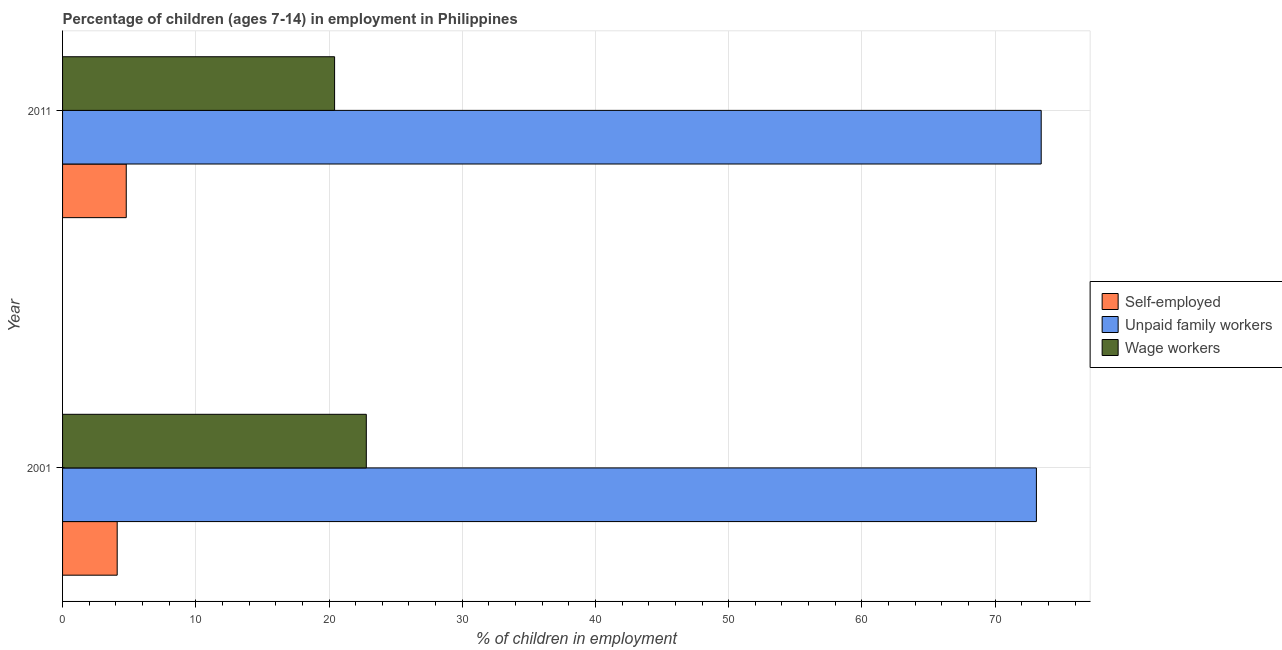How many groups of bars are there?
Provide a short and direct response. 2. Are the number of bars per tick equal to the number of legend labels?
Provide a succinct answer. Yes. What is the label of the 2nd group of bars from the top?
Make the answer very short. 2001. In how many cases, is the number of bars for a given year not equal to the number of legend labels?
Keep it short and to the point. 0. What is the percentage of children employed as wage workers in 2011?
Provide a succinct answer. 20.42. Across all years, what is the maximum percentage of self employed children?
Your response must be concise. 4.78. Across all years, what is the minimum percentage of children employed as wage workers?
Provide a succinct answer. 20.42. In which year was the percentage of self employed children maximum?
Offer a very short reply. 2011. In which year was the percentage of children employed as unpaid family workers minimum?
Keep it short and to the point. 2001. What is the total percentage of children employed as wage workers in the graph?
Keep it short and to the point. 43.22. What is the difference between the percentage of self employed children in 2001 and that in 2011?
Offer a very short reply. -0.68. What is the difference between the percentage of children employed as wage workers in 2001 and the percentage of children employed as unpaid family workers in 2011?
Offer a terse response. -50.66. What is the average percentage of self employed children per year?
Ensure brevity in your answer.  4.44. In the year 2001, what is the difference between the percentage of children employed as wage workers and percentage of self employed children?
Offer a terse response. 18.7. What is the ratio of the percentage of self employed children in 2001 to that in 2011?
Offer a very short reply. 0.86. Is the percentage of self employed children in 2001 less than that in 2011?
Ensure brevity in your answer.  Yes. Is the difference between the percentage of children employed as wage workers in 2001 and 2011 greater than the difference between the percentage of self employed children in 2001 and 2011?
Provide a short and direct response. Yes. In how many years, is the percentage of self employed children greater than the average percentage of self employed children taken over all years?
Your answer should be very brief. 1. What does the 3rd bar from the top in 2001 represents?
Offer a terse response. Self-employed. What does the 2nd bar from the bottom in 2011 represents?
Make the answer very short. Unpaid family workers. Is it the case that in every year, the sum of the percentage of self employed children and percentage of children employed as unpaid family workers is greater than the percentage of children employed as wage workers?
Offer a terse response. Yes. How many bars are there?
Your response must be concise. 6. Are all the bars in the graph horizontal?
Your answer should be very brief. Yes. Are the values on the major ticks of X-axis written in scientific E-notation?
Provide a short and direct response. No. Does the graph contain grids?
Give a very brief answer. Yes. How many legend labels are there?
Give a very brief answer. 3. How are the legend labels stacked?
Make the answer very short. Vertical. What is the title of the graph?
Keep it short and to the point. Percentage of children (ages 7-14) in employment in Philippines. What is the label or title of the X-axis?
Offer a very short reply. % of children in employment. What is the % of children in employment in Unpaid family workers in 2001?
Your answer should be very brief. 73.1. What is the % of children in employment of Wage workers in 2001?
Give a very brief answer. 22.8. What is the % of children in employment in Self-employed in 2011?
Give a very brief answer. 4.78. What is the % of children in employment of Unpaid family workers in 2011?
Offer a very short reply. 73.46. What is the % of children in employment in Wage workers in 2011?
Provide a succinct answer. 20.42. Across all years, what is the maximum % of children in employment in Self-employed?
Your answer should be compact. 4.78. Across all years, what is the maximum % of children in employment of Unpaid family workers?
Provide a succinct answer. 73.46. Across all years, what is the maximum % of children in employment in Wage workers?
Give a very brief answer. 22.8. Across all years, what is the minimum % of children in employment of Unpaid family workers?
Offer a terse response. 73.1. Across all years, what is the minimum % of children in employment of Wage workers?
Provide a succinct answer. 20.42. What is the total % of children in employment in Self-employed in the graph?
Your answer should be compact. 8.88. What is the total % of children in employment of Unpaid family workers in the graph?
Provide a short and direct response. 146.56. What is the total % of children in employment in Wage workers in the graph?
Offer a terse response. 43.22. What is the difference between the % of children in employment of Self-employed in 2001 and that in 2011?
Your answer should be compact. -0.68. What is the difference between the % of children in employment in Unpaid family workers in 2001 and that in 2011?
Offer a terse response. -0.36. What is the difference between the % of children in employment in Wage workers in 2001 and that in 2011?
Ensure brevity in your answer.  2.38. What is the difference between the % of children in employment of Self-employed in 2001 and the % of children in employment of Unpaid family workers in 2011?
Your answer should be very brief. -69.36. What is the difference between the % of children in employment of Self-employed in 2001 and the % of children in employment of Wage workers in 2011?
Provide a succinct answer. -16.32. What is the difference between the % of children in employment of Unpaid family workers in 2001 and the % of children in employment of Wage workers in 2011?
Give a very brief answer. 52.68. What is the average % of children in employment of Self-employed per year?
Give a very brief answer. 4.44. What is the average % of children in employment of Unpaid family workers per year?
Give a very brief answer. 73.28. What is the average % of children in employment of Wage workers per year?
Ensure brevity in your answer.  21.61. In the year 2001, what is the difference between the % of children in employment of Self-employed and % of children in employment of Unpaid family workers?
Make the answer very short. -69. In the year 2001, what is the difference between the % of children in employment in Self-employed and % of children in employment in Wage workers?
Provide a succinct answer. -18.7. In the year 2001, what is the difference between the % of children in employment in Unpaid family workers and % of children in employment in Wage workers?
Keep it short and to the point. 50.3. In the year 2011, what is the difference between the % of children in employment in Self-employed and % of children in employment in Unpaid family workers?
Provide a short and direct response. -68.68. In the year 2011, what is the difference between the % of children in employment in Self-employed and % of children in employment in Wage workers?
Your answer should be compact. -15.64. In the year 2011, what is the difference between the % of children in employment of Unpaid family workers and % of children in employment of Wage workers?
Your answer should be compact. 53.04. What is the ratio of the % of children in employment in Self-employed in 2001 to that in 2011?
Offer a very short reply. 0.86. What is the ratio of the % of children in employment in Wage workers in 2001 to that in 2011?
Give a very brief answer. 1.12. What is the difference between the highest and the second highest % of children in employment in Self-employed?
Your answer should be compact. 0.68. What is the difference between the highest and the second highest % of children in employment of Unpaid family workers?
Provide a short and direct response. 0.36. What is the difference between the highest and the second highest % of children in employment in Wage workers?
Provide a short and direct response. 2.38. What is the difference between the highest and the lowest % of children in employment of Self-employed?
Provide a succinct answer. 0.68. What is the difference between the highest and the lowest % of children in employment of Unpaid family workers?
Offer a terse response. 0.36. What is the difference between the highest and the lowest % of children in employment of Wage workers?
Ensure brevity in your answer.  2.38. 